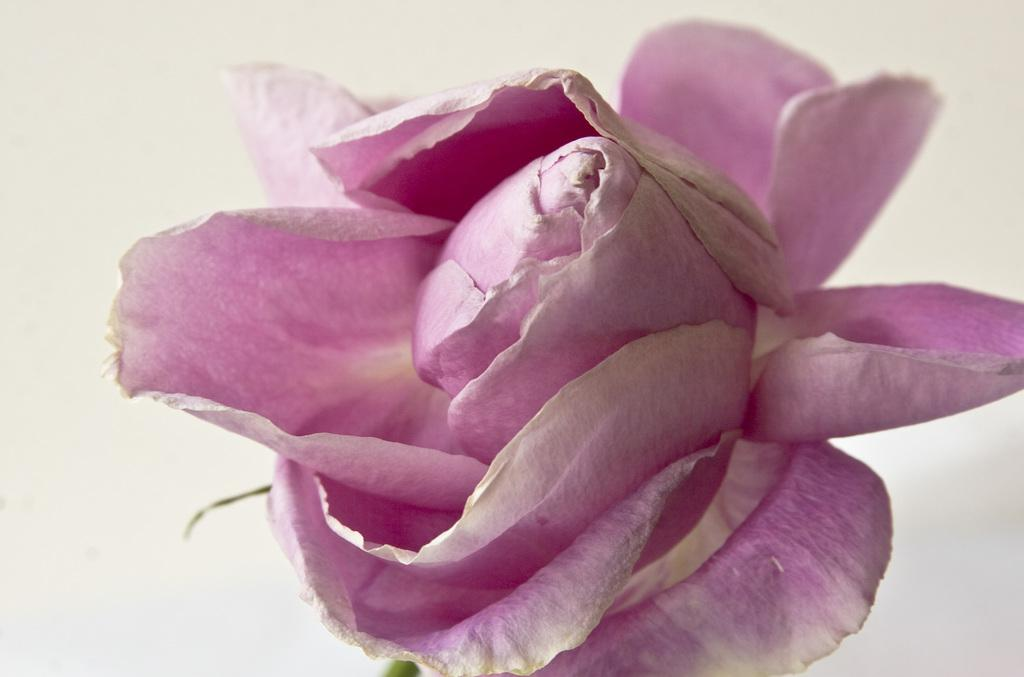What is the main subject of the picture? The main subject of the picture is a flower. How many petals does the flower have? The flower has many petals. What is the color of the surface on which the flower is placed? The flower is placed on a white surface. Reasoning: Let' Let's think step by step in order to produce the conversation. We start by identifying the main subject of the image, which is the flower. Next, we describe a specific characteristic of the flower, which is the number of petals. Finally, we mention the color of the surface on which the flower is placed, which is white. Absurd Question/Answer: What is the smell of the flower on the side of the image? The image does not convey the smell of the flower, and there is no mention of a side in the provided facts. 